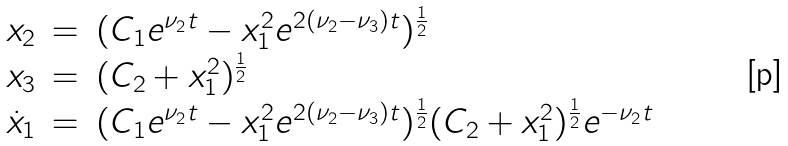Convert formula to latex. <formula><loc_0><loc_0><loc_500><loc_500>\begin{array} { l l l } x _ { 2 } & = & ( C _ { 1 } e ^ { \nu _ { 2 } t } - x _ { 1 } ^ { 2 } e ^ { 2 ( \nu _ { 2 } - \nu _ { 3 } ) t } ) ^ { \frac { 1 } { 2 } } \\ x _ { 3 } & = & ( C _ { 2 } + x _ { 1 } ^ { 2 } ) ^ { \frac { 1 } { 2 } } \\ \dot { x } _ { 1 } & = & ( C _ { 1 } e ^ { \nu _ { 2 } t } - x _ { 1 } ^ { 2 } e ^ { 2 ( \nu _ { 2 } - \nu _ { 3 } ) t } ) ^ { \frac { 1 } { 2 } } ( C _ { 2 } + x _ { 1 } ^ { 2 } ) ^ { \frac { 1 } { 2 } } e ^ { - \nu _ { 2 } t } \\ \end{array}</formula> 